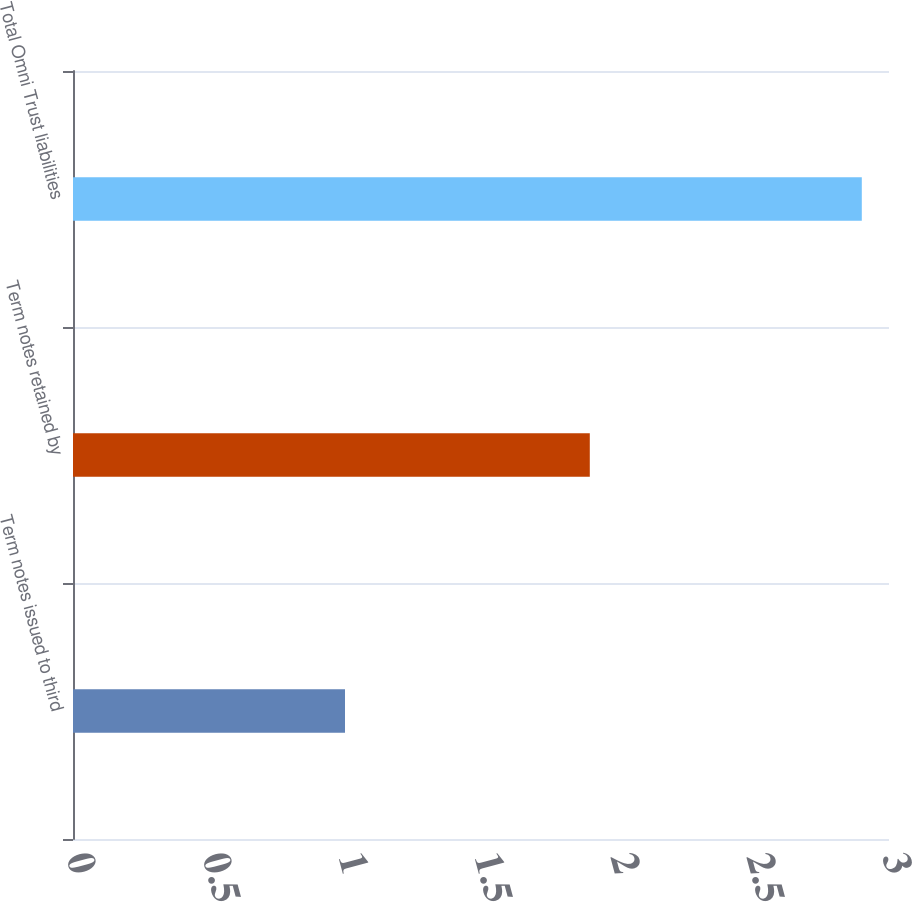Convert chart. <chart><loc_0><loc_0><loc_500><loc_500><bar_chart><fcel>Term notes issued to third<fcel>Term notes retained by<fcel>Total Omni Trust liabilities<nl><fcel>1<fcel>1.9<fcel>2.9<nl></chart> 